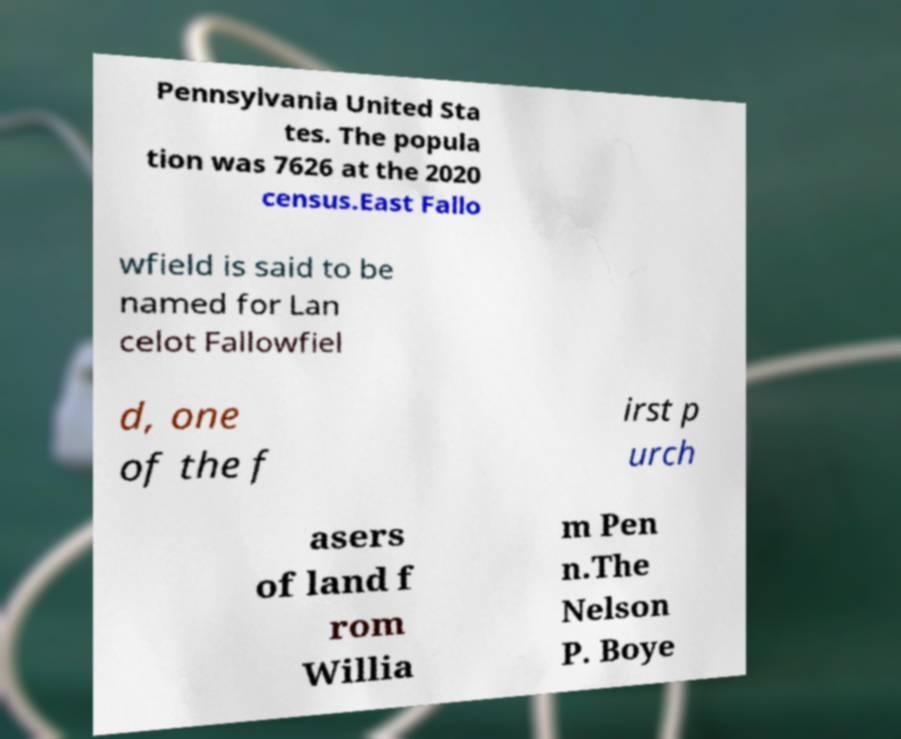There's text embedded in this image that I need extracted. Can you transcribe it verbatim? Pennsylvania United Sta tes. The popula tion was 7626 at the 2020 census.East Fallo wfield is said to be named for Lan celot Fallowfiel d, one of the f irst p urch asers of land f rom Willia m Pen n.The Nelson P. Boye 